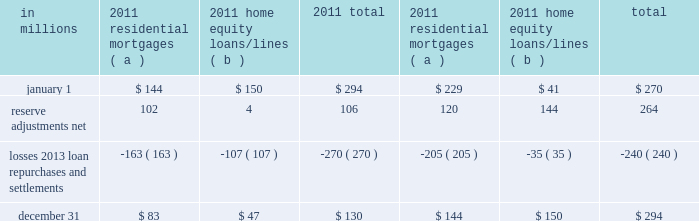Agreements associated with the agency securitizations , most sale agreements do not provide for penalties or other remedies if we do not respond timely to investor indemnification or repurchase requests .
Origination and sale of residential mortgages is an ongoing business activity and , accordingly , management continually assesses the need to recognize indemnification and repurchase liabilities pursuant to the associated investor sale agreements .
We establish indemnification and repurchase liabilities for estimated losses on sold first and second-lien mortgages and home equity loans/lines for which indemnification is expected to be provided or for loans that are expected to be repurchased .
For the first and second-lien mortgage sold portfolio , we have established an indemnification and repurchase liability pursuant to investor sale agreements based on claims made and our estimate of future claims on a loan by loan basis .
These relate primarily to loans originated during 2006-2008 .
For the home equity loans/lines sold portfolio , we have established indemnification and repurchase liabilities based upon this same methodology for loans sold during 2005-2007 .
Indemnification and repurchase liabilities are initially recognized when loans are sold to investors and are subsequently evaluated by management .
Initial recognition and subsequent adjustments to the indemnification and repurchase liability for the sold residential mortgage portfolio are recognized in residential mortgage revenue on the consolidated income statement .
Since pnc is no longer engaged in the brokered home equity lending business , only subsequent adjustments are recognized to the home equity loans/lines indemnification and repurchase liability .
These adjustments are recognized in other noninterest income on the consolidated income statement .
Management 2019s subsequent evaluation of these indemnification and repurchase liabilities is based upon trends in indemnification and repurchase requests , actual loss experience , risks in the underlying serviced loan portfolios , and current economic conditions .
As part of its evaluation , management considers estimated loss projections over the life of the subject loan portfolio .
At december 31 , 2011 and december 31 , 2010 , the total indemnification and repurchase liability for estimated losses on indemnification and repurchase claims totaled $ 130 million and $ 294 million , respectively , and was included in other liabilities on the consolidated balance sheet .
An analysis of the changes in this liability during 2011 and 2010 follows : analysis of indemnification and repurchase liability for asserted claims and unasserted claims .
( a ) repurchase obligation associated with sold loan portfolios of $ 121.4 billion and $ 139.8 billion at december 31 , 2011 and december 31 , 2010 , respectively .
( b ) repurchase obligation associated with sold loan portfolios of $ 4.5 billion and $ 6.5 billion at december 31 , 2011 and december 31 , 2010 , respectively .
Pnc is no longer engaged in the brokered home equity lending business , which was acquired with national city .
Management believes our indemnification and repurchase liabilities appropriately reflect the estimated probable losses on investor indemnification and repurchase claims at december 31 , 2011 and 2010 .
While management seeks to obtain all relevant information in estimating the indemnification and repurchase liability , the estimation process is inherently uncertain and imprecise and , accordingly , it is reasonably possible that future indemnification and repurchase losses could be more or less than our established liability .
Factors that could affect our estimate include the volume of valid claims driven by investor strategies and behavior , our ability to successfully negotiate claims with investors , housing prices , and other economic conditions .
At december 31 , 2011 , we estimate that it is reasonably possible that we could incur additional losses in excess of our indemnification and repurchase liability of up to $ 85 million .
This estimate of potential additional losses in excess of our liability is based on assumed higher investor demands , lower claim rescissions , and lower home prices than our current assumptions .
Reinsurance agreements we have two wholly-owned captive insurance subsidiaries which provide reinsurance to third-party insurers related to insurance sold to our customers .
These subsidiaries enter into various types of reinsurance agreements with third-party insurers where the subsidiary assumes the risk of loss through either an excess of loss or quota share agreement up to 100% ( 100 % ) reinsurance .
In excess of loss agreements , these subsidiaries assume the risk of loss for an excess layer of coverage up to specified limits , once a defined first loss percentage is met .
In quota share agreements , the subsidiaries and third-party insurers share the responsibility for payment of all claims .
These subsidiaries provide reinsurance for accidental death & dismemberment , credit life , accident & health , lender placed 200 the pnc financial services group , inc .
2013 form 10-k .
What is the difference in millions between residential mortgages as of jan 1 , 2011 and dec 31 , 2011? 
Rationale: both years listed as 2011
Computations: (144 - 83)
Answer: 61.0. 